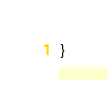<code> <loc_0><loc_0><loc_500><loc_500><_C++_>}

</code> 